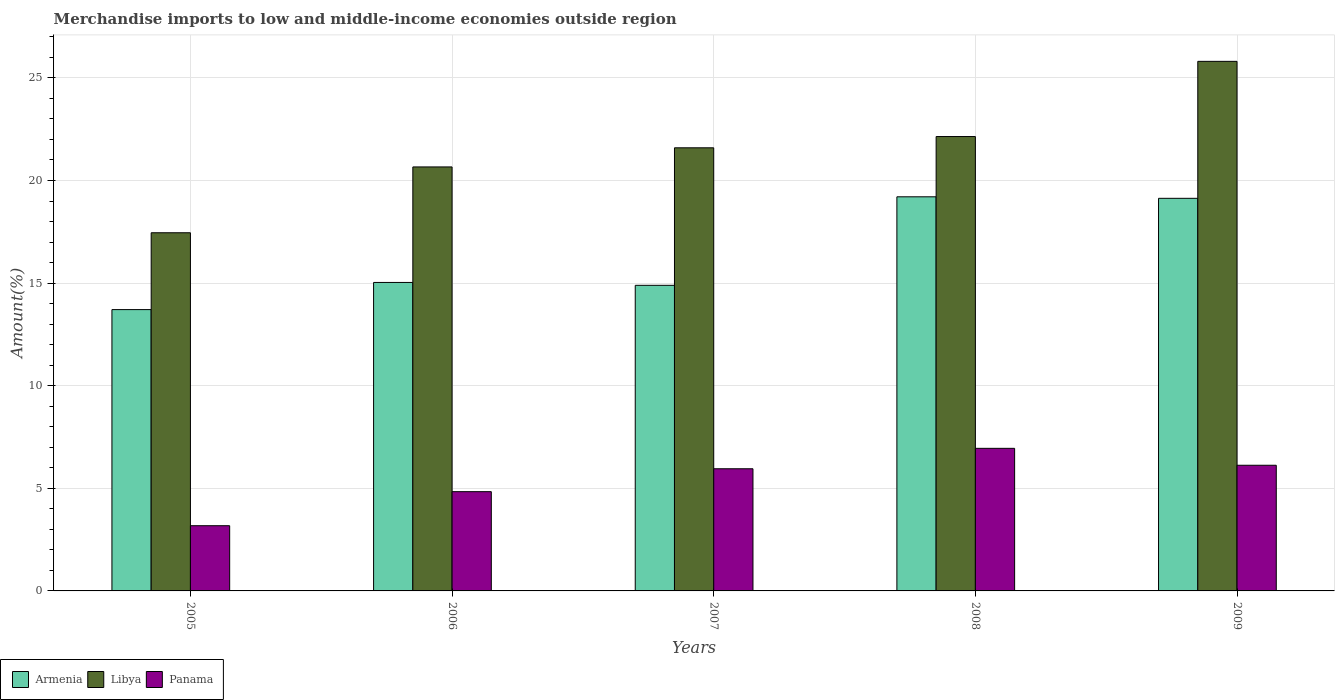Are the number of bars per tick equal to the number of legend labels?
Your answer should be very brief. Yes. Are the number of bars on each tick of the X-axis equal?
Provide a succinct answer. Yes. How many bars are there on the 1st tick from the left?
Keep it short and to the point. 3. What is the label of the 2nd group of bars from the left?
Ensure brevity in your answer.  2006. What is the percentage of amount earned from merchandise imports in Panama in 2006?
Ensure brevity in your answer.  4.84. Across all years, what is the maximum percentage of amount earned from merchandise imports in Armenia?
Offer a very short reply. 19.2. Across all years, what is the minimum percentage of amount earned from merchandise imports in Panama?
Ensure brevity in your answer.  3.18. In which year was the percentage of amount earned from merchandise imports in Libya maximum?
Provide a short and direct response. 2009. What is the total percentage of amount earned from merchandise imports in Armenia in the graph?
Keep it short and to the point. 81.97. What is the difference between the percentage of amount earned from merchandise imports in Panama in 2006 and that in 2008?
Ensure brevity in your answer.  -2.11. What is the difference between the percentage of amount earned from merchandise imports in Panama in 2007 and the percentage of amount earned from merchandise imports in Armenia in 2005?
Your answer should be compact. -7.76. What is the average percentage of amount earned from merchandise imports in Armenia per year?
Make the answer very short. 16.39. In the year 2007, what is the difference between the percentage of amount earned from merchandise imports in Panama and percentage of amount earned from merchandise imports in Libya?
Keep it short and to the point. -15.64. What is the ratio of the percentage of amount earned from merchandise imports in Armenia in 2008 to that in 2009?
Keep it short and to the point. 1. Is the difference between the percentage of amount earned from merchandise imports in Panama in 2005 and 2009 greater than the difference between the percentage of amount earned from merchandise imports in Libya in 2005 and 2009?
Offer a terse response. Yes. What is the difference between the highest and the second highest percentage of amount earned from merchandise imports in Panama?
Keep it short and to the point. 0.82. What is the difference between the highest and the lowest percentage of amount earned from merchandise imports in Libya?
Ensure brevity in your answer.  8.35. In how many years, is the percentage of amount earned from merchandise imports in Libya greater than the average percentage of amount earned from merchandise imports in Libya taken over all years?
Your answer should be very brief. 3. What does the 3rd bar from the left in 2008 represents?
Provide a succinct answer. Panama. What does the 1st bar from the right in 2007 represents?
Your answer should be compact. Panama. Is it the case that in every year, the sum of the percentage of amount earned from merchandise imports in Panama and percentage of amount earned from merchandise imports in Libya is greater than the percentage of amount earned from merchandise imports in Armenia?
Offer a very short reply. Yes. Are the values on the major ticks of Y-axis written in scientific E-notation?
Your response must be concise. No. Does the graph contain any zero values?
Provide a succinct answer. No. Does the graph contain grids?
Offer a terse response. Yes. How many legend labels are there?
Your answer should be compact. 3. What is the title of the graph?
Offer a very short reply. Merchandise imports to low and middle-income economies outside region. What is the label or title of the Y-axis?
Keep it short and to the point. Amount(%). What is the Amount(%) of Armenia in 2005?
Your response must be concise. 13.71. What is the Amount(%) of Libya in 2005?
Give a very brief answer. 17.45. What is the Amount(%) in Panama in 2005?
Offer a terse response. 3.18. What is the Amount(%) in Armenia in 2006?
Give a very brief answer. 15.03. What is the Amount(%) of Libya in 2006?
Provide a short and direct response. 20.66. What is the Amount(%) of Panama in 2006?
Your answer should be very brief. 4.84. What is the Amount(%) of Armenia in 2007?
Give a very brief answer. 14.89. What is the Amount(%) of Libya in 2007?
Your response must be concise. 21.59. What is the Amount(%) of Panama in 2007?
Make the answer very short. 5.95. What is the Amount(%) of Armenia in 2008?
Offer a terse response. 19.2. What is the Amount(%) in Libya in 2008?
Make the answer very short. 22.14. What is the Amount(%) of Panama in 2008?
Provide a short and direct response. 6.95. What is the Amount(%) of Armenia in 2009?
Keep it short and to the point. 19.13. What is the Amount(%) of Libya in 2009?
Ensure brevity in your answer.  25.81. What is the Amount(%) of Panama in 2009?
Offer a very short reply. 6.12. Across all years, what is the maximum Amount(%) of Armenia?
Ensure brevity in your answer.  19.2. Across all years, what is the maximum Amount(%) of Libya?
Offer a terse response. 25.81. Across all years, what is the maximum Amount(%) in Panama?
Provide a succinct answer. 6.95. Across all years, what is the minimum Amount(%) of Armenia?
Provide a succinct answer. 13.71. Across all years, what is the minimum Amount(%) of Libya?
Provide a short and direct response. 17.45. Across all years, what is the minimum Amount(%) in Panama?
Provide a succinct answer. 3.18. What is the total Amount(%) of Armenia in the graph?
Your answer should be compact. 81.97. What is the total Amount(%) in Libya in the graph?
Provide a short and direct response. 107.65. What is the total Amount(%) of Panama in the graph?
Make the answer very short. 27.04. What is the difference between the Amount(%) in Armenia in 2005 and that in 2006?
Provide a short and direct response. -1.32. What is the difference between the Amount(%) in Libya in 2005 and that in 2006?
Your response must be concise. -3.21. What is the difference between the Amount(%) in Panama in 2005 and that in 2006?
Your answer should be compact. -1.66. What is the difference between the Amount(%) of Armenia in 2005 and that in 2007?
Your answer should be very brief. -1.18. What is the difference between the Amount(%) in Libya in 2005 and that in 2007?
Your answer should be compact. -4.14. What is the difference between the Amount(%) of Panama in 2005 and that in 2007?
Offer a very short reply. -2.78. What is the difference between the Amount(%) of Armenia in 2005 and that in 2008?
Give a very brief answer. -5.5. What is the difference between the Amount(%) in Libya in 2005 and that in 2008?
Your answer should be very brief. -4.69. What is the difference between the Amount(%) of Panama in 2005 and that in 2008?
Ensure brevity in your answer.  -3.77. What is the difference between the Amount(%) of Armenia in 2005 and that in 2009?
Ensure brevity in your answer.  -5.42. What is the difference between the Amount(%) in Libya in 2005 and that in 2009?
Provide a succinct answer. -8.35. What is the difference between the Amount(%) in Panama in 2005 and that in 2009?
Keep it short and to the point. -2.95. What is the difference between the Amount(%) of Armenia in 2006 and that in 2007?
Ensure brevity in your answer.  0.14. What is the difference between the Amount(%) of Libya in 2006 and that in 2007?
Offer a very short reply. -0.93. What is the difference between the Amount(%) in Panama in 2006 and that in 2007?
Offer a terse response. -1.12. What is the difference between the Amount(%) of Armenia in 2006 and that in 2008?
Your answer should be compact. -4.17. What is the difference between the Amount(%) in Libya in 2006 and that in 2008?
Your answer should be very brief. -1.48. What is the difference between the Amount(%) in Panama in 2006 and that in 2008?
Provide a succinct answer. -2.11. What is the difference between the Amount(%) of Armenia in 2006 and that in 2009?
Provide a succinct answer. -4.1. What is the difference between the Amount(%) in Libya in 2006 and that in 2009?
Make the answer very short. -5.14. What is the difference between the Amount(%) of Panama in 2006 and that in 2009?
Make the answer very short. -1.29. What is the difference between the Amount(%) in Armenia in 2007 and that in 2008?
Your response must be concise. -4.31. What is the difference between the Amount(%) of Libya in 2007 and that in 2008?
Offer a terse response. -0.55. What is the difference between the Amount(%) in Panama in 2007 and that in 2008?
Keep it short and to the point. -1. What is the difference between the Amount(%) of Armenia in 2007 and that in 2009?
Ensure brevity in your answer.  -4.24. What is the difference between the Amount(%) in Libya in 2007 and that in 2009?
Your answer should be very brief. -4.21. What is the difference between the Amount(%) of Panama in 2007 and that in 2009?
Provide a succinct answer. -0.17. What is the difference between the Amount(%) of Armenia in 2008 and that in 2009?
Provide a short and direct response. 0.07. What is the difference between the Amount(%) in Libya in 2008 and that in 2009?
Provide a short and direct response. -3.66. What is the difference between the Amount(%) in Panama in 2008 and that in 2009?
Keep it short and to the point. 0.82. What is the difference between the Amount(%) of Armenia in 2005 and the Amount(%) of Libya in 2006?
Offer a terse response. -6.95. What is the difference between the Amount(%) in Armenia in 2005 and the Amount(%) in Panama in 2006?
Provide a short and direct response. 8.87. What is the difference between the Amount(%) in Libya in 2005 and the Amount(%) in Panama in 2006?
Ensure brevity in your answer.  12.62. What is the difference between the Amount(%) in Armenia in 2005 and the Amount(%) in Libya in 2007?
Give a very brief answer. -7.88. What is the difference between the Amount(%) in Armenia in 2005 and the Amount(%) in Panama in 2007?
Offer a very short reply. 7.76. What is the difference between the Amount(%) of Libya in 2005 and the Amount(%) of Panama in 2007?
Provide a short and direct response. 11.5. What is the difference between the Amount(%) in Armenia in 2005 and the Amount(%) in Libya in 2008?
Your response must be concise. -8.43. What is the difference between the Amount(%) in Armenia in 2005 and the Amount(%) in Panama in 2008?
Ensure brevity in your answer.  6.76. What is the difference between the Amount(%) of Libya in 2005 and the Amount(%) of Panama in 2008?
Ensure brevity in your answer.  10.5. What is the difference between the Amount(%) in Armenia in 2005 and the Amount(%) in Libya in 2009?
Your answer should be compact. -12.1. What is the difference between the Amount(%) in Armenia in 2005 and the Amount(%) in Panama in 2009?
Your answer should be very brief. 7.58. What is the difference between the Amount(%) in Libya in 2005 and the Amount(%) in Panama in 2009?
Give a very brief answer. 11.33. What is the difference between the Amount(%) of Armenia in 2006 and the Amount(%) of Libya in 2007?
Your answer should be very brief. -6.56. What is the difference between the Amount(%) of Armenia in 2006 and the Amount(%) of Panama in 2007?
Your answer should be very brief. 9.08. What is the difference between the Amount(%) in Libya in 2006 and the Amount(%) in Panama in 2007?
Ensure brevity in your answer.  14.71. What is the difference between the Amount(%) of Armenia in 2006 and the Amount(%) of Libya in 2008?
Your answer should be very brief. -7.11. What is the difference between the Amount(%) of Armenia in 2006 and the Amount(%) of Panama in 2008?
Give a very brief answer. 8.08. What is the difference between the Amount(%) in Libya in 2006 and the Amount(%) in Panama in 2008?
Keep it short and to the point. 13.71. What is the difference between the Amount(%) in Armenia in 2006 and the Amount(%) in Libya in 2009?
Provide a short and direct response. -10.77. What is the difference between the Amount(%) in Armenia in 2006 and the Amount(%) in Panama in 2009?
Provide a succinct answer. 8.91. What is the difference between the Amount(%) of Libya in 2006 and the Amount(%) of Panama in 2009?
Your answer should be very brief. 14.54. What is the difference between the Amount(%) in Armenia in 2007 and the Amount(%) in Libya in 2008?
Offer a terse response. -7.25. What is the difference between the Amount(%) of Armenia in 2007 and the Amount(%) of Panama in 2008?
Your response must be concise. 7.94. What is the difference between the Amount(%) in Libya in 2007 and the Amount(%) in Panama in 2008?
Ensure brevity in your answer.  14.64. What is the difference between the Amount(%) of Armenia in 2007 and the Amount(%) of Libya in 2009?
Provide a succinct answer. -10.91. What is the difference between the Amount(%) in Armenia in 2007 and the Amount(%) in Panama in 2009?
Offer a very short reply. 8.77. What is the difference between the Amount(%) in Libya in 2007 and the Amount(%) in Panama in 2009?
Keep it short and to the point. 15.47. What is the difference between the Amount(%) in Armenia in 2008 and the Amount(%) in Libya in 2009?
Make the answer very short. -6.6. What is the difference between the Amount(%) in Armenia in 2008 and the Amount(%) in Panama in 2009?
Make the answer very short. 13.08. What is the difference between the Amount(%) in Libya in 2008 and the Amount(%) in Panama in 2009?
Give a very brief answer. 16.02. What is the average Amount(%) in Armenia per year?
Your response must be concise. 16.39. What is the average Amount(%) in Libya per year?
Keep it short and to the point. 21.53. What is the average Amount(%) in Panama per year?
Your answer should be compact. 5.41. In the year 2005, what is the difference between the Amount(%) of Armenia and Amount(%) of Libya?
Your answer should be compact. -3.74. In the year 2005, what is the difference between the Amount(%) in Armenia and Amount(%) in Panama?
Ensure brevity in your answer.  10.53. In the year 2005, what is the difference between the Amount(%) in Libya and Amount(%) in Panama?
Give a very brief answer. 14.28. In the year 2006, what is the difference between the Amount(%) in Armenia and Amount(%) in Libya?
Your answer should be very brief. -5.63. In the year 2006, what is the difference between the Amount(%) of Armenia and Amount(%) of Panama?
Offer a terse response. 10.19. In the year 2006, what is the difference between the Amount(%) in Libya and Amount(%) in Panama?
Keep it short and to the point. 15.82. In the year 2007, what is the difference between the Amount(%) of Armenia and Amount(%) of Libya?
Your answer should be compact. -6.7. In the year 2007, what is the difference between the Amount(%) in Armenia and Amount(%) in Panama?
Ensure brevity in your answer.  8.94. In the year 2007, what is the difference between the Amount(%) in Libya and Amount(%) in Panama?
Offer a very short reply. 15.64. In the year 2008, what is the difference between the Amount(%) in Armenia and Amount(%) in Libya?
Provide a short and direct response. -2.94. In the year 2008, what is the difference between the Amount(%) in Armenia and Amount(%) in Panama?
Give a very brief answer. 12.26. In the year 2008, what is the difference between the Amount(%) of Libya and Amount(%) of Panama?
Your answer should be very brief. 15.19. In the year 2009, what is the difference between the Amount(%) in Armenia and Amount(%) in Libya?
Your answer should be compact. -6.67. In the year 2009, what is the difference between the Amount(%) in Armenia and Amount(%) in Panama?
Make the answer very short. 13.01. In the year 2009, what is the difference between the Amount(%) in Libya and Amount(%) in Panama?
Offer a terse response. 19.68. What is the ratio of the Amount(%) of Armenia in 2005 to that in 2006?
Offer a very short reply. 0.91. What is the ratio of the Amount(%) of Libya in 2005 to that in 2006?
Offer a terse response. 0.84. What is the ratio of the Amount(%) in Panama in 2005 to that in 2006?
Provide a succinct answer. 0.66. What is the ratio of the Amount(%) in Armenia in 2005 to that in 2007?
Keep it short and to the point. 0.92. What is the ratio of the Amount(%) in Libya in 2005 to that in 2007?
Keep it short and to the point. 0.81. What is the ratio of the Amount(%) of Panama in 2005 to that in 2007?
Your response must be concise. 0.53. What is the ratio of the Amount(%) of Armenia in 2005 to that in 2008?
Provide a succinct answer. 0.71. What is the ratio of the Amount(%) in Libya in 2005 to that in 2008?
Keep it short and to the point. 0.79. What is the ratio of the Amount(%) of Panama in 2005 to that in 2008?
Offer a terse response. 0.46. What is the ratio of the Amount(%) of Armenia in 2005 to that in 2009?
Your response must be concise. 0.72. What is the ratio of the Amount(%) in Libya in 2005 to that in 2009?
Ensure brevity in your answer.  0.68. What is the ratio of the Amount(%) in Panama in 2005 to that in 2009?
Offer a terse response. 0.52. What is the ratio of the Amount(%) in Armenia in 2006 to that in 2007?
Keep it short and to the point. 1.01. What is the ratio of the Amount(%) in Libya in 2006 to that in 2007?
Provide a succinct answer. 0.96. What is the ratio of the Amount(%) of Panama in 2006 to that in 2007?
Make the answer very short. 0.81. What is the ratio of the Amount(%) of Armenia in 2006 to that in 2008?
Offer a very short reply. 0.78. What is the ratio of the Amount(%) in Libya in 2006 to that in 2008?
Your response must be concise. 0.93. What is the ratio of the Amount(%) in Panama in 2006 to that in 2008?
Your answer should be very brief. 0.7. What is the ratio of the Amount(%) of Armenia in 2006 to that in 2009?
Your answer should be compact. 0.79. What is the ratio of the Amount(%) in Libya in 2006 to that in 2009?
Your answer should be compact. 0.8. What is the ratio of the Amount(%) in Panama in 2006 to that in 2009?
Offer a very short reply. 0.79. What is the ratio of the Amount(%) of Armenia in 2007 to that in 2008?
Your response must be concise. 0.78. What is the ratio of the Amount(%) in Libya in 2007 to that in 2008?
Keep it short and to the point. 0.98. What is the ratio of the Amount(%) of Panama in 2007 to that in 2008?
Your answer should be compact. 0.86. What is the ratio of the Amount(%) in Armenia in 2007 to that in 2009?
Keep it short and to the point. 0.78. What is the ratio of the Amount(%) of Libya in 2007 to that in 2009?
Offer a terse response. 0.84. What is the ratio of the Amount(%) of Panama in 2007 to that in 2009?
Your response must be concise. 0.97. What is the ratio of the Amount(%) in Libya in 2008 to that in 2009?
Keep it short and to the point. 0.86. What is the ratio of the Amount(%) of Panama in 2008 to that in 2009?
Your answer should be very brief. 1.13. What is the difference between the highest and the second highest Amount(%) in Armenia?
Make the answer very short. 0.07. What is the difference between the highest and the second highest Amount(%) of Libya?
Give a very brief answer. 3.66. What is the difference between the highest and the second highest Amount(%) of Panama?
Offer a terse response. 0.82. What is the difference between the highest and the lowest Amount(%) in Armenia?
Provide a succinct answer. 5.5. What is the difference between the highest and the lowest Amount(%) in Libya?
Your answer should be compact. 8.35. What is the difference between the highest and the lowest Amount(%) of Panama?
Offer a very short reply. 3.77. 